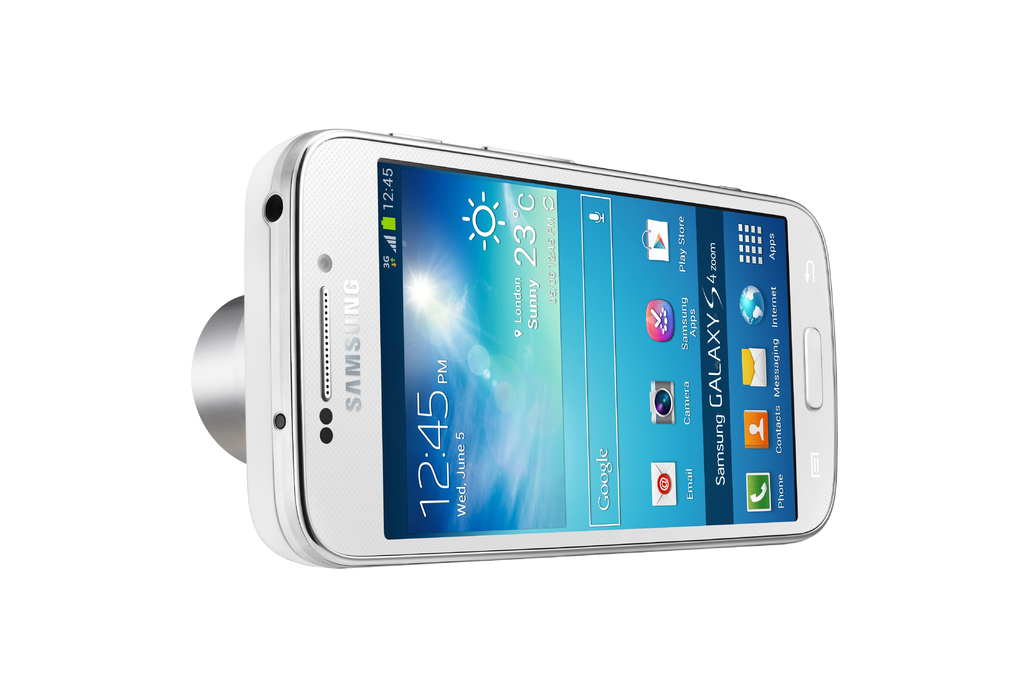Describe the design aesthetic of the Samsung Galaxy S4 shown in this image. The Samsung Galaxy S4 featured in the image has a sleek, modern design with a rounded metallic edge and a large touchscreen interface. The layout is minimalist and user-centric, focusing on ease of access to frequently used features. 